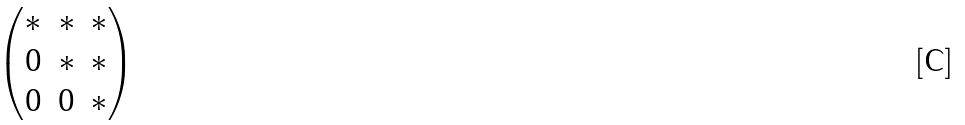<formula> <loc_0><loc_0><loc_500><loc_500>\begin{pmatrix} * & * & * \\ 0 & * & * \\ 0 & 0 & * \end{pmatrix}</formula> 